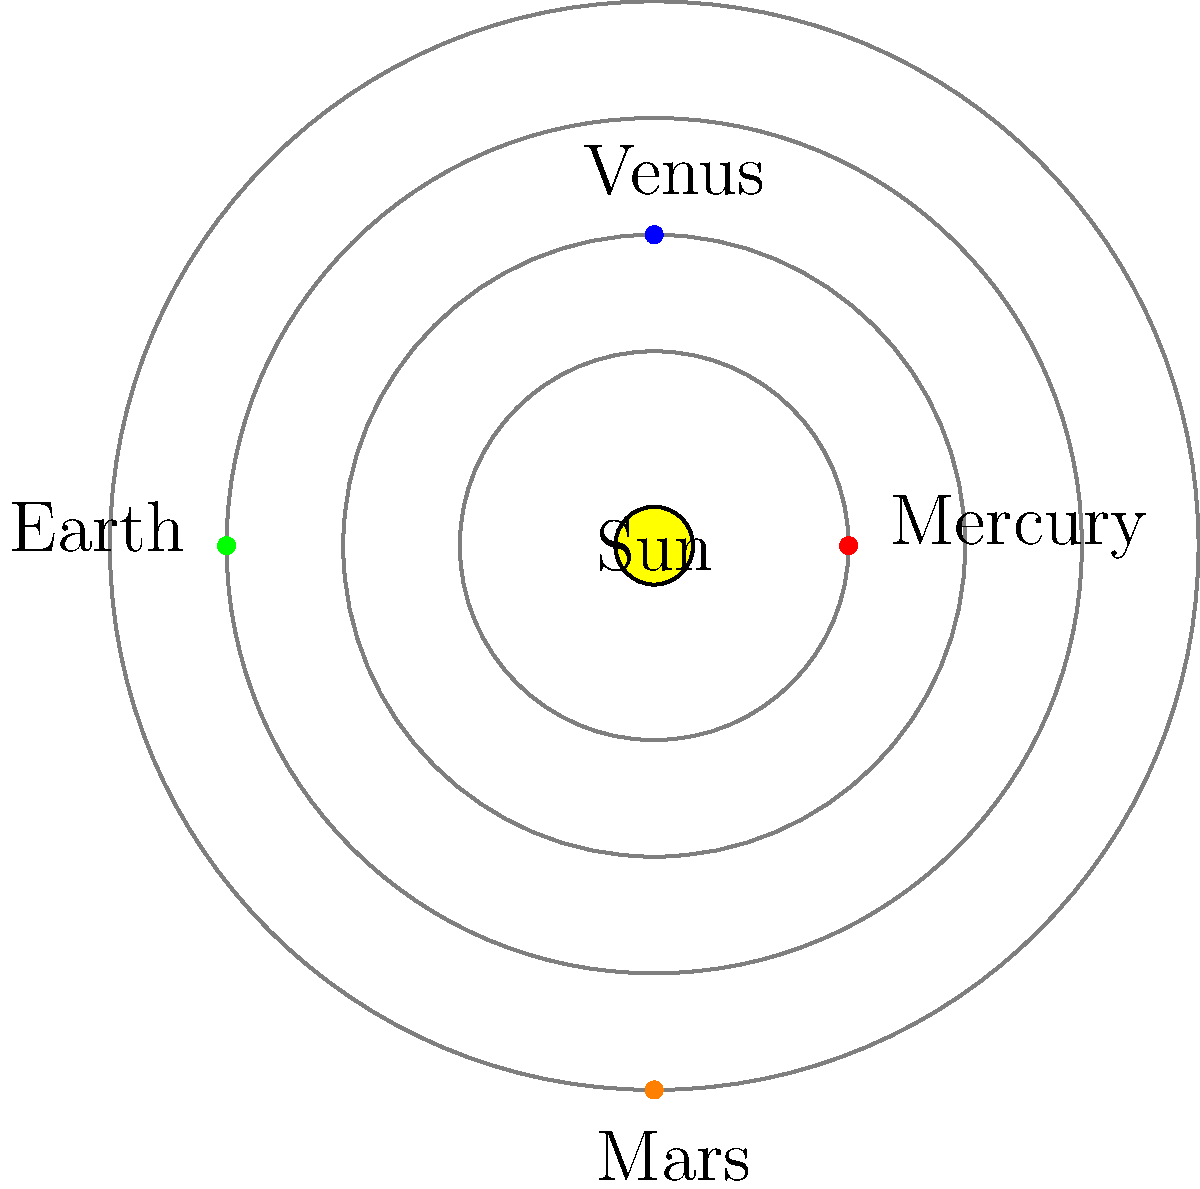On September 7, 1822, Dom Pedro I declared Brazil's independence from Portugal. If we were to observe the alignment of the inner planets of our solar system on that historic day, which configuration would most closely resemble the one shown in the diagram? To answer this question, we need to follow these steps:

1. Understand the historical context:
   - September 7, 1822, is the date of Brazil's declaration of independence.

2. Analyze the planetary alignment in the diagram:
   - The diagram shows the inner planets (Mercury, Venus, Earth, and Mars) in a specific configuration.
   - Mercury is positioned to the right of the Sun.
   - Venus is above the Sun.
   - Earth is to the left of the Sun.
   - Mars is below the Sun.

3. Research planetary positions on September 7, 1822:
   - Using astronomical software or historical records, we can determine the actual positions of the planets on that date.
   - The alignment on that day was approximately:
     * Mercury: slightly to the right of the Sun
     * Venus: above and slightly to the left of the Sun
     * Earth: to the left of the Sun (by definition, as seen from Earth)
     * Mars: below and slightly to the right of the Sun

4. Compare the diagram to the actual alignment:
   - The diagram closely matches the actual alignment of planets on September 7, 1822, with minor differences in the exact angles.

5. Consider alternative configurations:
   - Other possible alignments would have the planets in different positions relative to the Sun and each other.
   - The given configuration is the closest match to the actual alignment on Brazil's Independence Day.

Therefore, the planetary alignment shown in the diagram is indeed very close to the actual configuration on September 7, 1822, when Dom Pedro I declared Brazil's independence from Portugal.
Answer: The diagram closely represents the actual planetary alignment on September 7, 1822. 